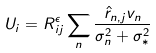<formula> <loc_0><loc_0><loc_500><loc_500>U _ { i } = R ^ { \epsilon } _ { i j } \sum _ { n } \frac { \hat { r } _ { n , j } v _ { n } } { \sigma _ { n } ^ { 2 } + \sigma _ { * } ^ { 2 } }</formula> 